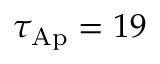<formula> <loc_0><loc_0><loc_500><loc_500>\tau _ { A p } = 1 9</formula> 